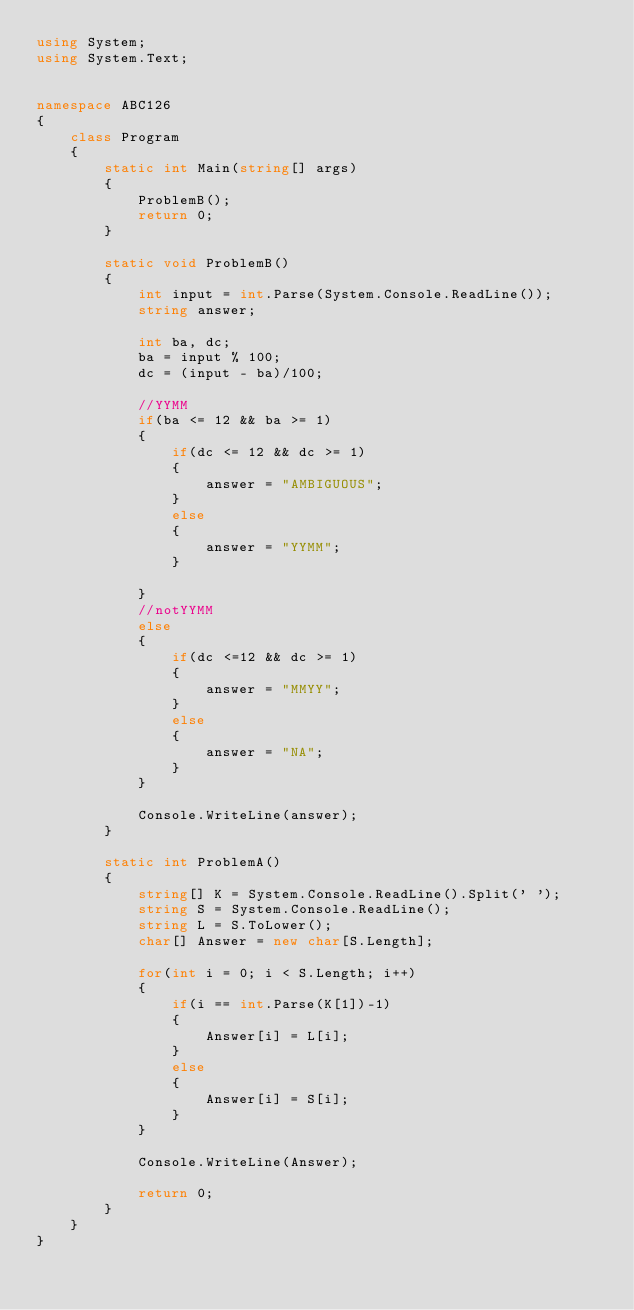<code> <loc_0><loc_0><loc_500><loc_500><_C#_>using System;
using System.Text;


namespace ABC126
{
    class Program
    {
        static int Main(string[] args)
        {
            ProblemB();
            return 0;
        }

        static void ProblemB()
        {
            int input = int.Parse(System.Console.ReadLine());
            string answer;

            int ba, dc;
            ba = input % 100;
            dc = (input - ba)/100;

            //YYMM
            if(ba <= 12 && ba >= 1)
            {
                if(dc <= 12 && dc >= 1)
                {
                    answer = "AMBIGUOUS";
                }
                else
                {
                    answer = "YYMM";
                }

            }
            //notYYMM
            else
            {
                if(dc <=12 && dc >= 1)
                {
                    answer = "MMYY";
                }
                else
                {
                    answer = "NA";
                }
            }

            Console.WriteLine(answer);
        }

        static int ProblemA()
        {
            string[] K = System.Console.ReadLine().Split(' ');
            string S = System.Console.ReadLine();
            string L = S.ToLower();
            char[] Answer = new char[S.Length];

            for(int i = 0; i < S.Length; i++)
            {
                if(i == int.Parse(K[1])-1)
                {
                    Answer[i] = L[i];
                }
                else
                {
                    Answer[i] = S[i];
                }
            }

            Console.WriteLine(Answer);

            return 0;
        }
    }
}
</code> 